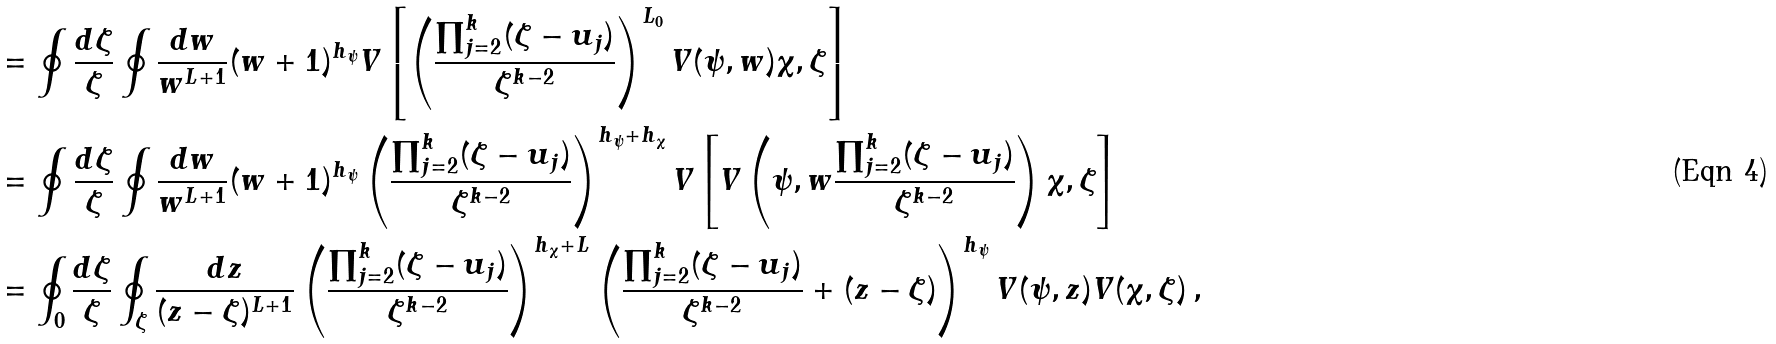<formula> <loc_0><loc_0><loc_500><loc_500>& = \oint \frac { d \zeta } { \zeta } \oint \frac { d w } { w ^ { L + 1 } } ( w + 1 ) ^ { h _ { \psi } } V \left [ \left ( \frac { \prod _ { j = 2 } ^ { k } ( \zeta - u _ { j } ) } { \zeta ^ { k - 2 } } \right ) ^ { L _ { 0 } } V ( \psi , w ) \chi , \zeta \right ] \\ & = \oint \frac { d \zeta } { \zeta } \oint \frac { d w } { w ^ { L + 1 } } ( w + 1 ) ^ { h _ { \psi } } \left ( \frac { \prod _ { j = 2 } ^ { k } ( \zeta - u _ { j } ) } { \zeta ^ { k - 2 } } \right ) ^ { h _ { \psi } + h _ { \chi } } V \left [ V \left ( \psi , w \frac { \prod _ { j = 2 } ^ { k } ( \zeta - u _ { j } ) } { \zeta ^ { k - 2 } } \right ) \chi , \zeta \right ] \\ & = \oint _ { 0 } \frac { d \zeta } { \zeta } \oint _ { \zeta } \frac { d z } { ( z - \zeta ) ^ { L + 1 } } \left ( \frac { \prod _ { j = 2 } ^ { k } ( \zeta - u _ { j } ) } { \zeta ^ { k - 2 } } \right ) ^ { h _ { \chi } + L } \left ( \frac { \prod _ { j = 2 } ^ { k } ( \zeta - u _ { j } ) } { \zeta ^ { k - 2 } } + ( z - \zeta ) \right ) ^ { h _ { \psi } } V ( \psi , z ) V ( \chi , \zeta ) \, ,</formula> 